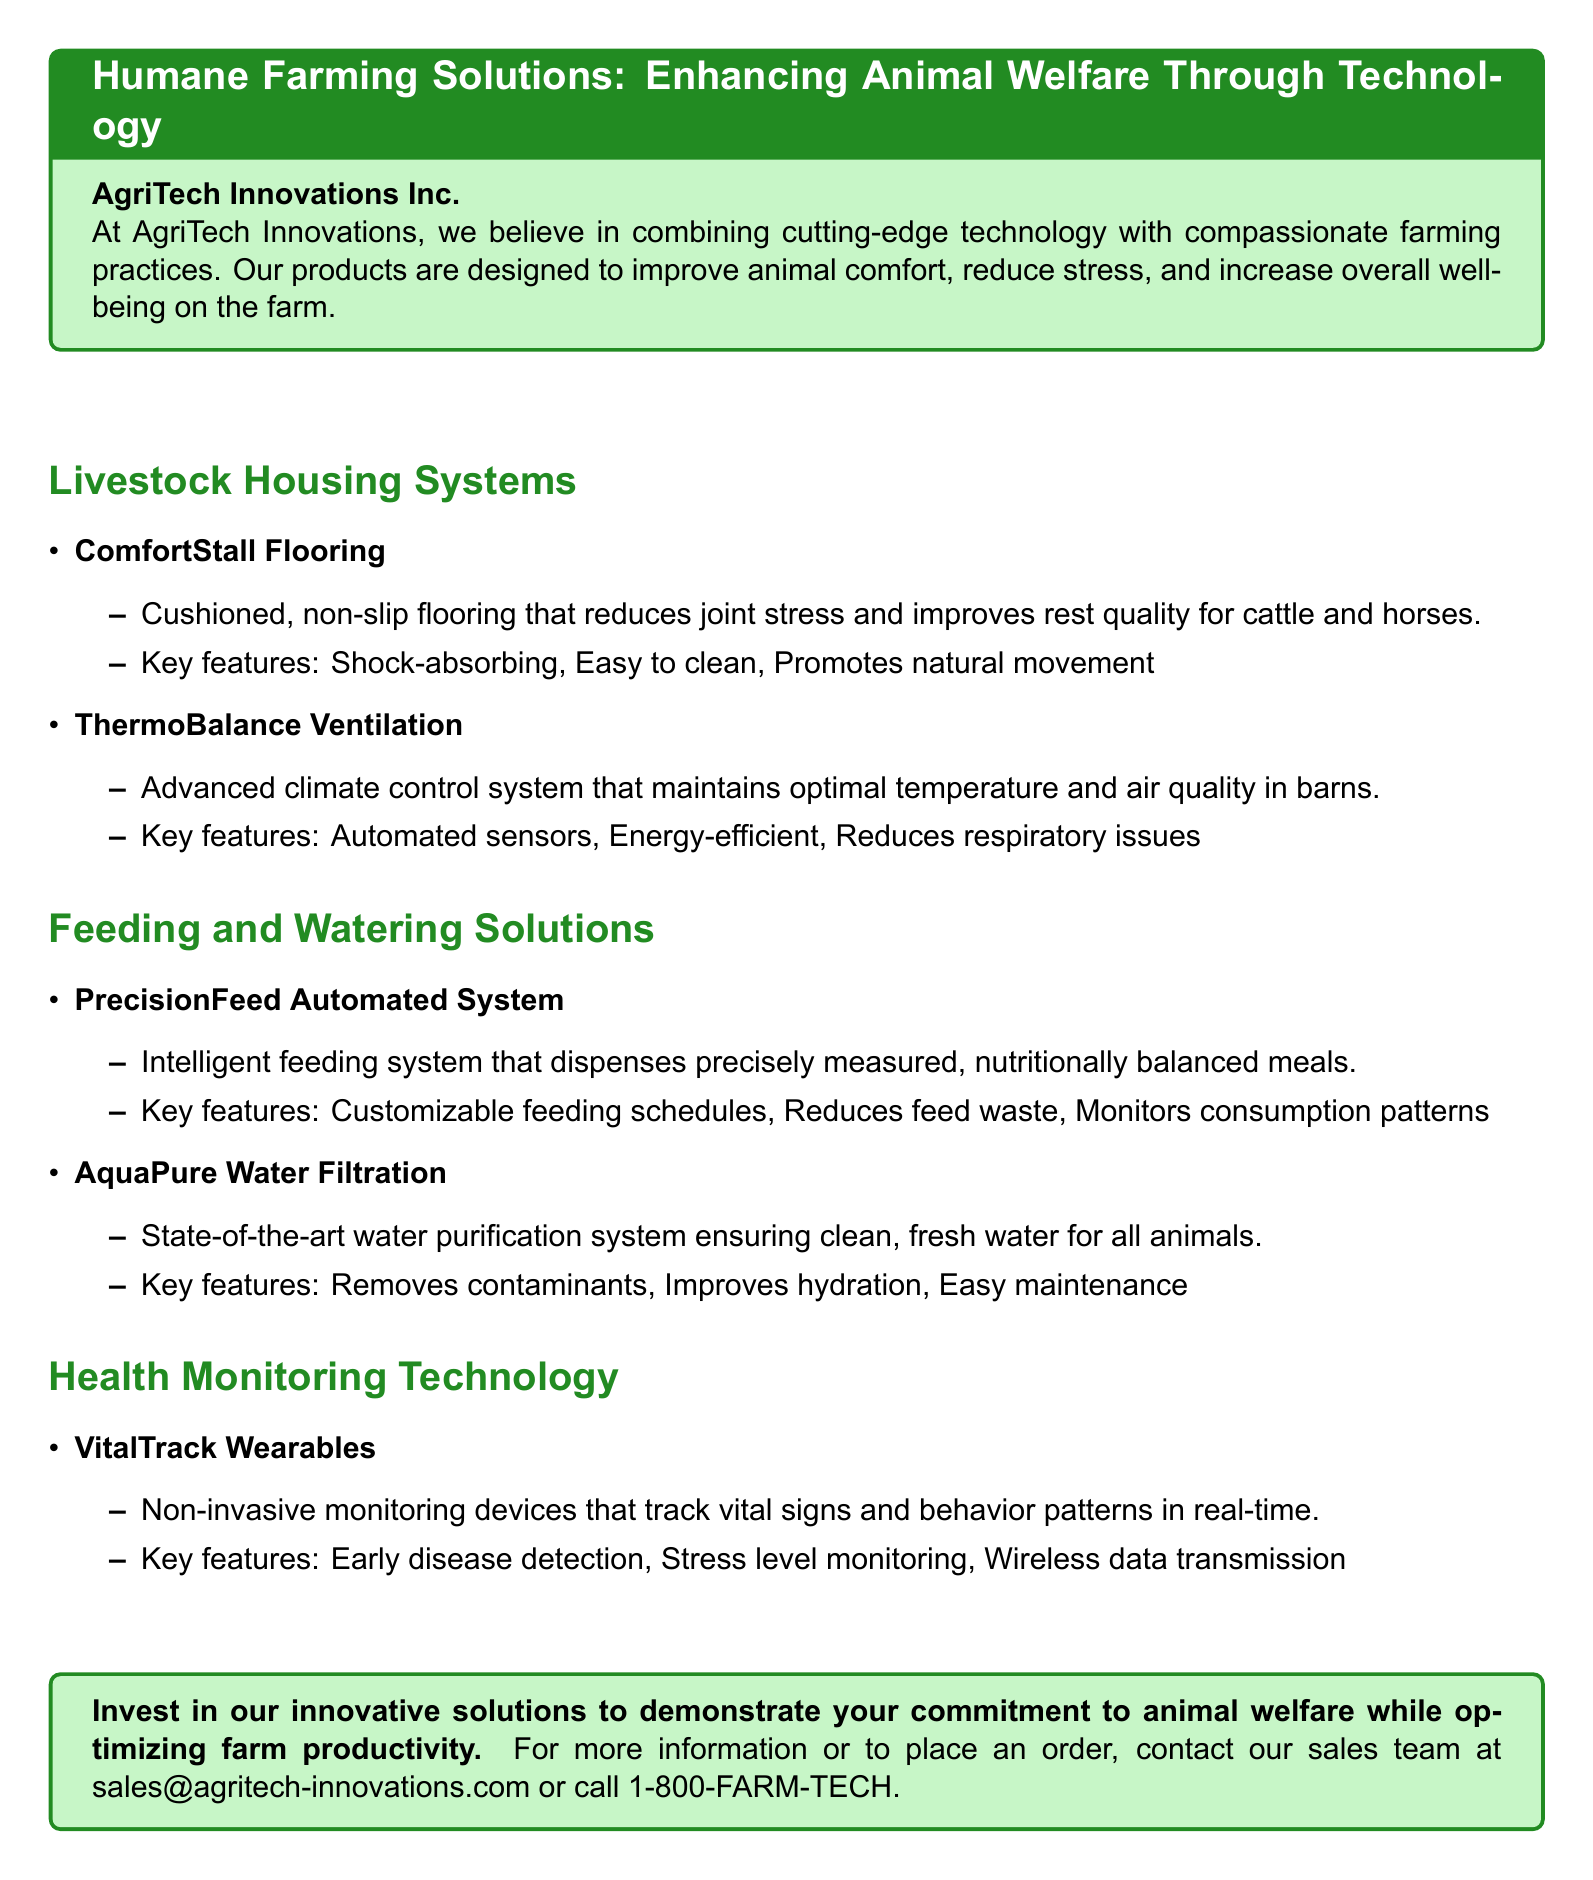What company offers these products? The document states that the products are offered by AgriTech Innovations Inc.
Answer: AgriTech Innovations Inc What is the name of the flooring system designed to improve animal comfort? The flooring system designed to improve animal comfort is called ComfortStall Flooring.
Answer: ComfortStall Flooring What feature does the ThermoBalance Ventilation system provide? The document mentions that the ThermoBalance Ventilation system maintains optimal temperature and air quality in barns.
Answer: Optimal temperature and air quality How does the PrecisionFeed Automated System help reduce waste? It reduces waste by dispensing precisely measured, nutritionally balanced meals.
Answer: Reduces feed waste What is the purpose of the VitalTrack Wearables? The VitalTrack Wearables are used to track vital signs and behavior patterns in real-time.
Answer: Track vital signs and behavior patterns What technology is used to ensure clean, fresh water for animals? The technology used is AquaPure Water Filtration.
Answer: AquaPure Water Filtration What type of monitoring do VitalTrack Wearables provide? They provide non-invasive monitoring of vital signs and behavior patterns.
Answer: Non-invasive monitoring Which solution improves hydration for animals? The solution that improves hydration for animals is AquaPure Water Filtration.
Answer: AquaPure Water Filtration 